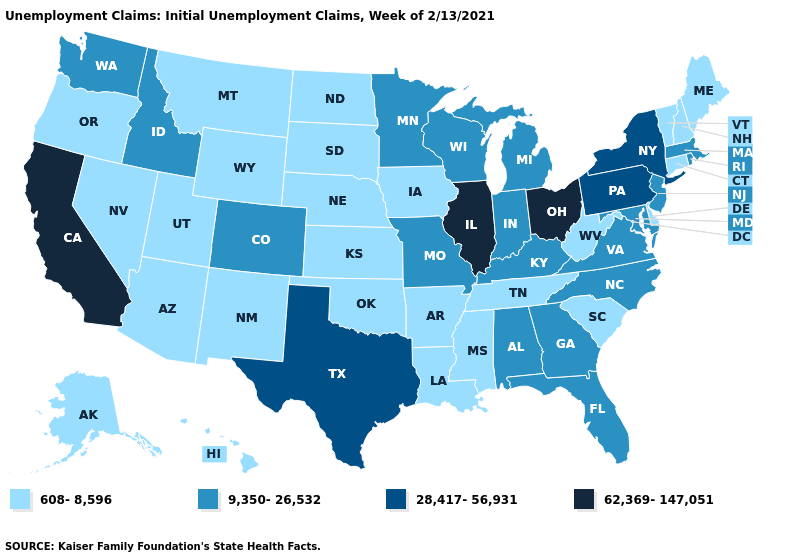Name the states that have a value in the range 62,369-147,051?
Answer briefly. California, Illinois, Ohio. Name the states that have a value in the range 9,350-26,532?
Quick response, please. Alabama, Colorado, Florida, Georgia, Idaho, Indiana, Kentucky, Maryland, Massachusetts, Michigan, Minnesota, Missouri, New Jersey, North Carolina, Rhode Island, Virginia, Washington, Wisconsin. What is the highest value in the Northeast ?
Give a very brief answer. 28,417-56,931. What is the value of South Dakota?
Short answer required. 608-8,596. Name the states that have a value in the range 62,369-147,051?
Keep it brief. California, Illinois, Ohio. Name the states that have a value in the range 9,350-26,532?
Short answer required. Alabama, Colorado, Florida, Georgia, Idaho, Indiana, Kentucky, Maryland, Massachusetts, Michigan, Minnesota, Missouri, New Jersey, North Carolina, Rhode Island, Virginia, Washington, Wisconsin. Does Illinois have a higher value than Ohio?
Quick response, please. No. What is the highest value in the West ?
Write a very short answer. 62,369-147,051. What is the lowest value in the USA?
Be succinct. 608-8,596. How many symbols are there in the legend?
Keep it brief. 4. What is the value of Massachusetts?
Concise answer only. 9,350-26,532. Name the states that have a value in the range 608-8,596?
Give a very brief answer. Alaska, Arizona, Arkansas, Connecticut, Delaware, Hawaii, Iowa, Kansas, Louisiana, Maine, Mississippi, Montana, Nebraska, Nevada, New Hampshire, New Mexico, North Dakota, Oklahoma, Oregon, South Carolina, South Dakota, Tennessee, Utah, Vermont, West Virginia, Wyoming. Among the states that border Ohio , which have the highest value?
Concise answer only. Pennsylvania. What is the value of Nebraska?
Short answer required. 608-8,596. What is the value of Montana?
Give a very brief answer. 608-8,596. 